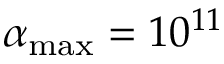Convert formula to latex. <formula><loc_0><loc_0><loc_500><loc_500>\alpha _ { \max } = 1 0 ^ { 1 1 }</formula> 